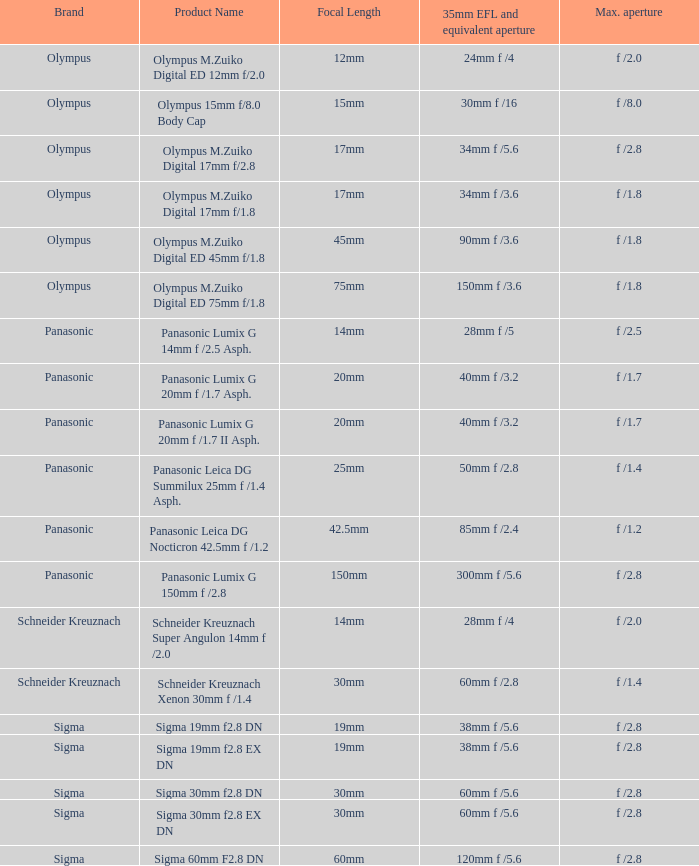What is the brand of the Sigma 30mm f2.8 DN, which has a maximum aperture of f /2.8 and a focal length of 30mm? Sigma. 